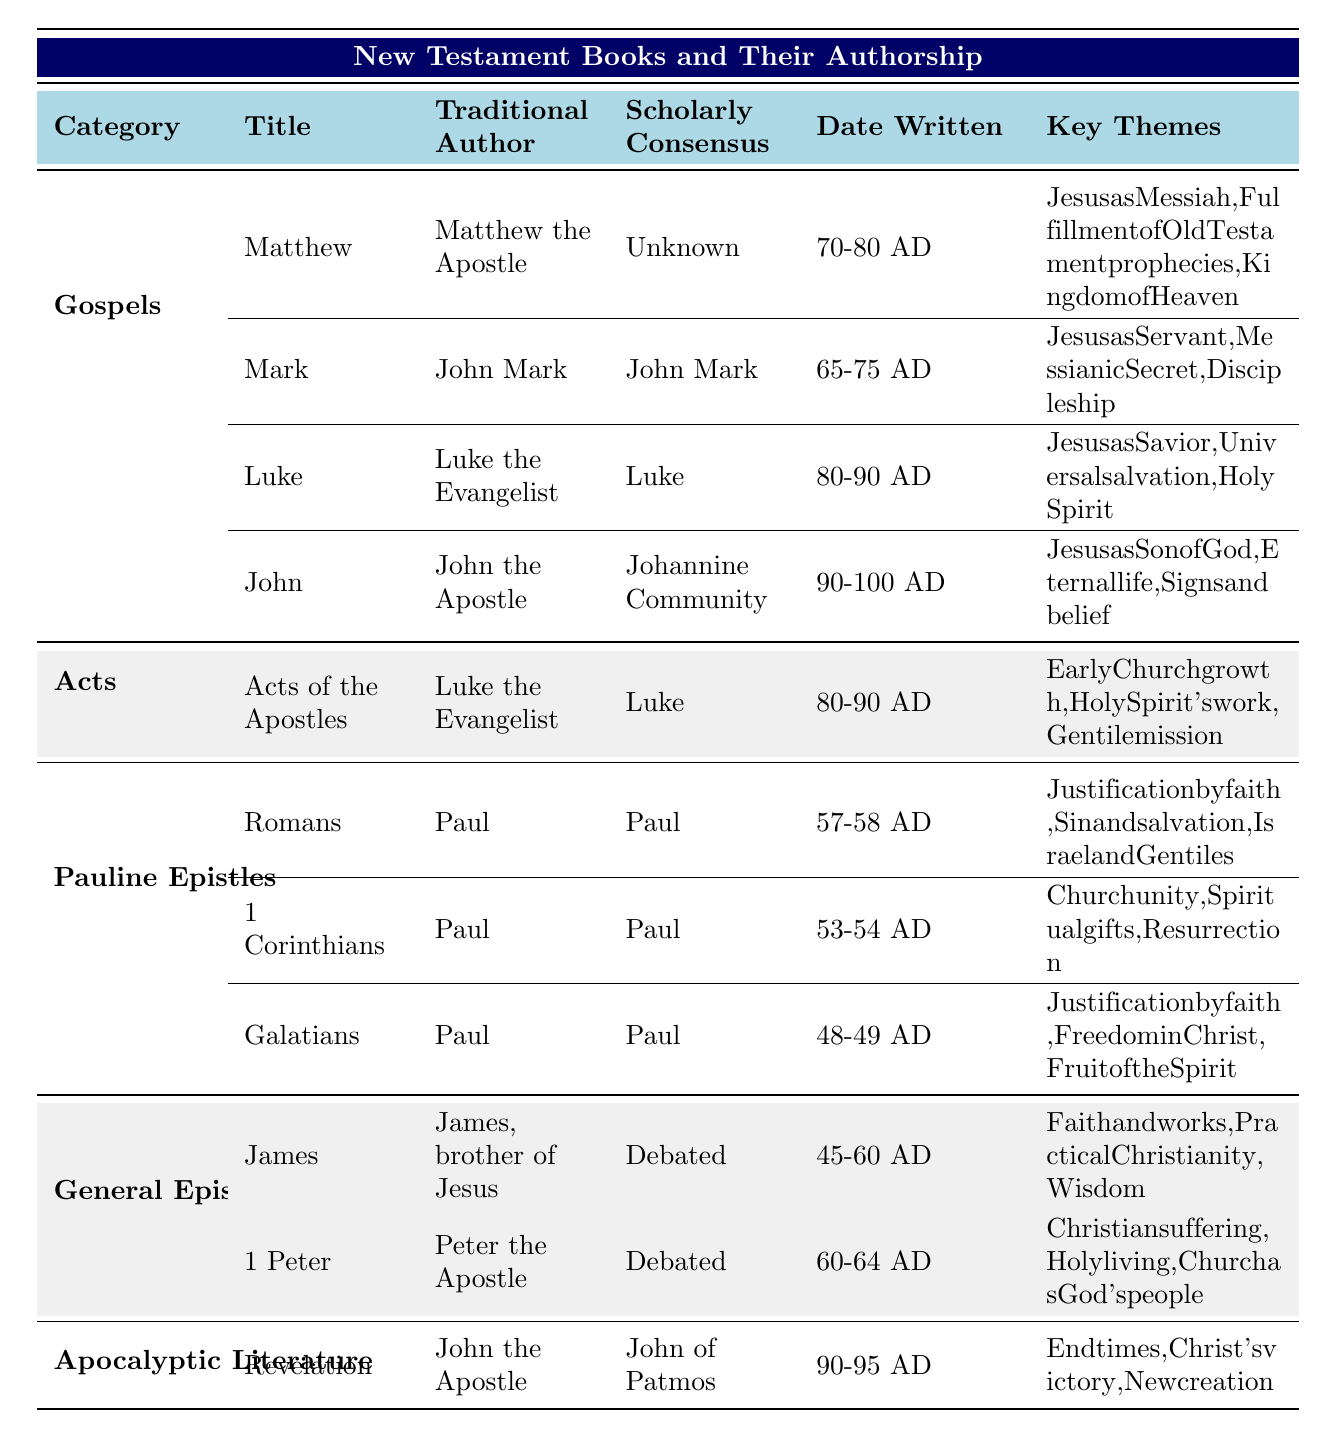What is the traditional author of the book of Mark? The table lists the traditional author of the book of Mark under the "Traditional Author" column. It shows that the traditional author is "John Mark."
Answer: John Mark Which book in the Gospels has a scholarly consensus of "Luke"? By examining the table, the book in the Gospels that has a scholarly consensus of "Luke" is "Luke."
Answer: Luke How many books are attributed to Paul in the Pauline Epistles category? The table shows three books under the "Pauline Epistles" category—Romans, 1 Corinthians, and Galatians. Therefore, the count is 3.
Answer: 3 What are the key themes of the book of Revelation? By referring to the table, the key themes listed for the book of Revelation are "End times, Christ's victory, New creation."
Answer: End times, Christ's victory, New creation Is "James" considered to have a debated authorship? The table indicates that the scholarly consensus for the book of James is listed as "Debated." Therefore, the answer is yes.
Answer: Yes Which Gospel was written last, based on the date written? The table shows that the Gospel of John has the latest date written (90-100 AD) while other Gospels have earlier dates. Thus, John was written last.
Answer: John What is the date range for the writing of the book of Galatians? According to the table, the date written for Galatians is from 48-49 AD.
Answer: 48-49 AD Compare the key themes of 1 Corinthians and Galatians—what is common? By looking at the key themes for both books in the table, Galatians includes "Justification by faith," which is also a key theme in Romans. However, there isn't a direct overlap in themes. Therefore, the common element is the theme of justification by faith shared with Romans.
Answer: Justification by faith What is the earliest-written book in the General Epistles category? The table shows that James, written between 45-60 AD, is the earliest among the General Epistles.
Answer: James Which author is mentioned in the traditional author column for the book of Acts? In the table, the traditional author for the book of Acts of the Apostles is listed as "Luke the Evangelist."
Answer: Luke the Evangelist What is the difference in years between the earliest date written for Paul's Epistles and the latest date written? The earliest date for Paul's epistles is 48-49 AD (Galatians), and the latest is 57-58 AD (Romans). The difference is calculated as follows: 58 - 49 = 9.
Answer: 9 years 